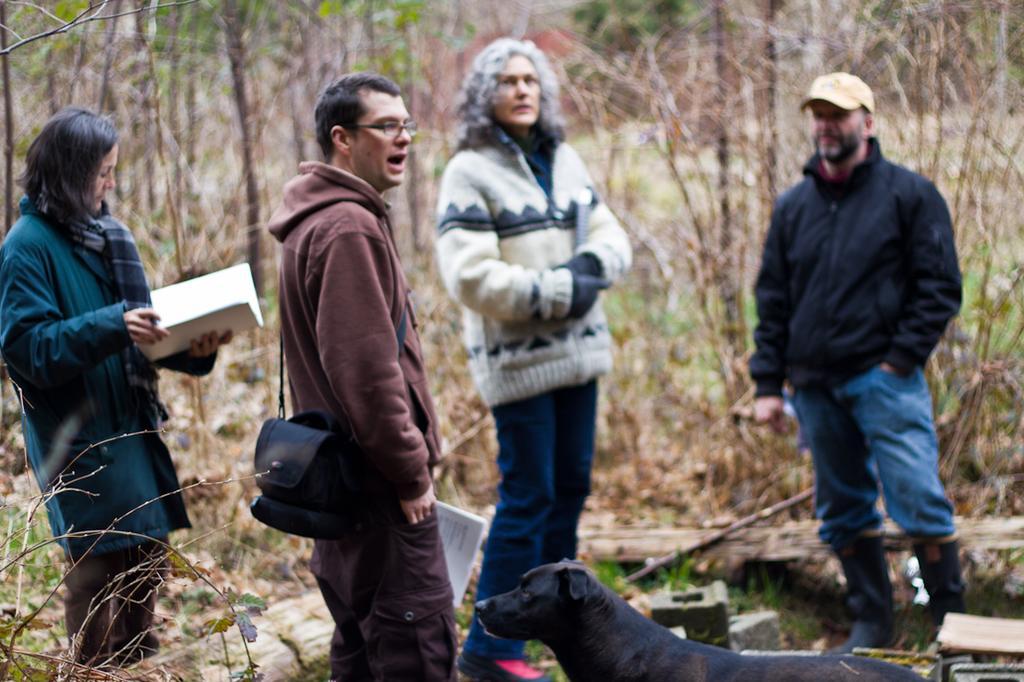Please provide a concise description of this image. In this image in the front there are persons standing. On the left side there is a woman standing and holding a book. In the front there is a dog which is black in colour. In the background there are dry trees and there are dry leaves on the ground. 